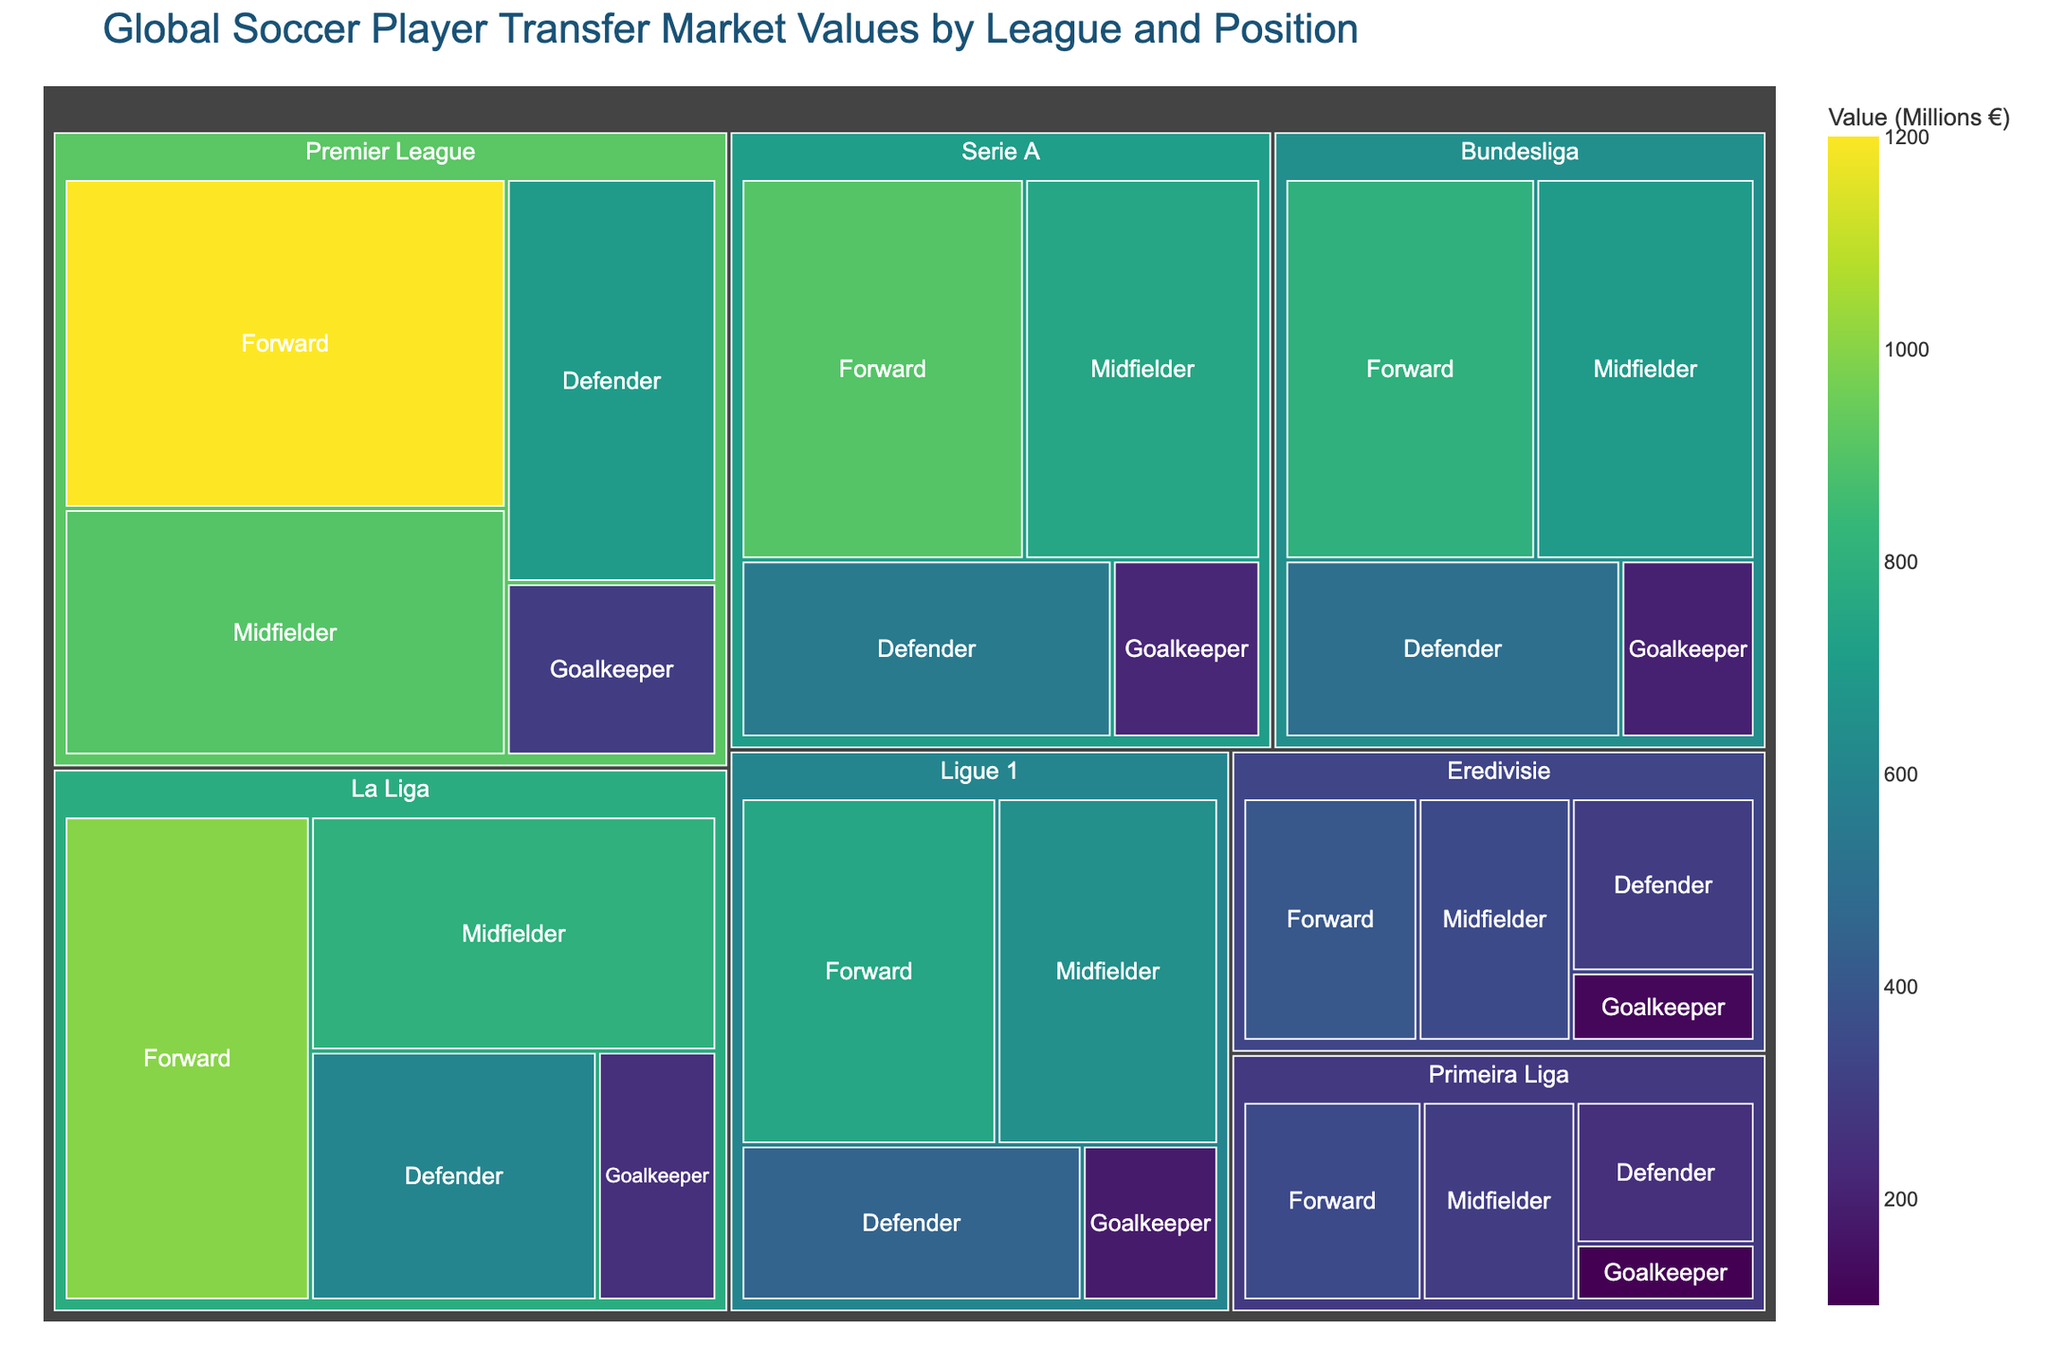What's the highest market value for a Forward, and which league does it come from? The highest value among Forwards is 1200, and it corresponds to the Premier League, as seen in the largest block for the position.
Answer: 1200, Premier League How does the transfer value of Goalkeepers in the Premier League compare to that in La Liga? The Premier League Goalkeepers have a value of 300, and La Liga Goalkeepers have a value of 250, as indicated by the corresponding blocks in the treemap.
Answer: Premier League: 300, La Liga: 250 What is the total transfer market value for all Forward positions across all leagues? Sum of all Forward positions: 1200 (Premier League) + 1000 (La Liga) + 800 (Bundesliga) + 900 (Serie A) + 750 (Ligue 1) + 400 (Eredivisie) + 350 (Primeira Liga) = 5400
Answer: 5400 Which league has the highest total value for defenders, and what is that value? The highest total value for defenders is in the Premier League with 700, as visualized by the relative size of the block compared to other leagues.
Answer: Premier League, 700 What is the difference in transfer value between Midfielders in Ligue 1 and Bundesliga? Midfielders in Ligue 1 have a value of 650, and in the Bundesliga, they have a value of 700. The difference is calculated as 700 - 650 = 50
Answer: 50 Which league has the smallest block for Goalkeepers, and what is its value? Primeira Liga has the smallest block for Goalkeepers with a value of 100. This can be identified by the smallest block size in the treemap.
Answer: Primeira Liga, 100 What is the average transfer value for Midfielders across all leagues? Sum of all Midfielder values: 900 (Premier League) + 800 (La Liga) + 700 (Bundesliga) + 750 (Serie A) + 650 (Ligue 1) + 350 (Eredivisie) + 300 (Primeira Liga) = 4450. Average = 4450 / 7 ≈ 636
Answer: 636 Comparing the sizes of blocks, which league has the lowest total transfer market value, and what is that value? Primeira Liga has the lowest total value, summing up Forward: 350 + Midfielder: 300 + Defender: 250 + Goalkeeper: 100 = 1000. This is the smallest total block in the treemap.
Answer: Primeira Liga, 1000 How does the value of Defenders in La Liga compare to the combined value of Defenders in Eredivisie and Primeira Liga? Defenders in La Liga have a value of 600. Combined value of Eredivisie and Primeira Liga Defenders: 300 + 250 = 550. La Liga (600) is greater than Eredivisie + Primeira Liga (550).
Answer: La Liga: 600, Combined: 550 